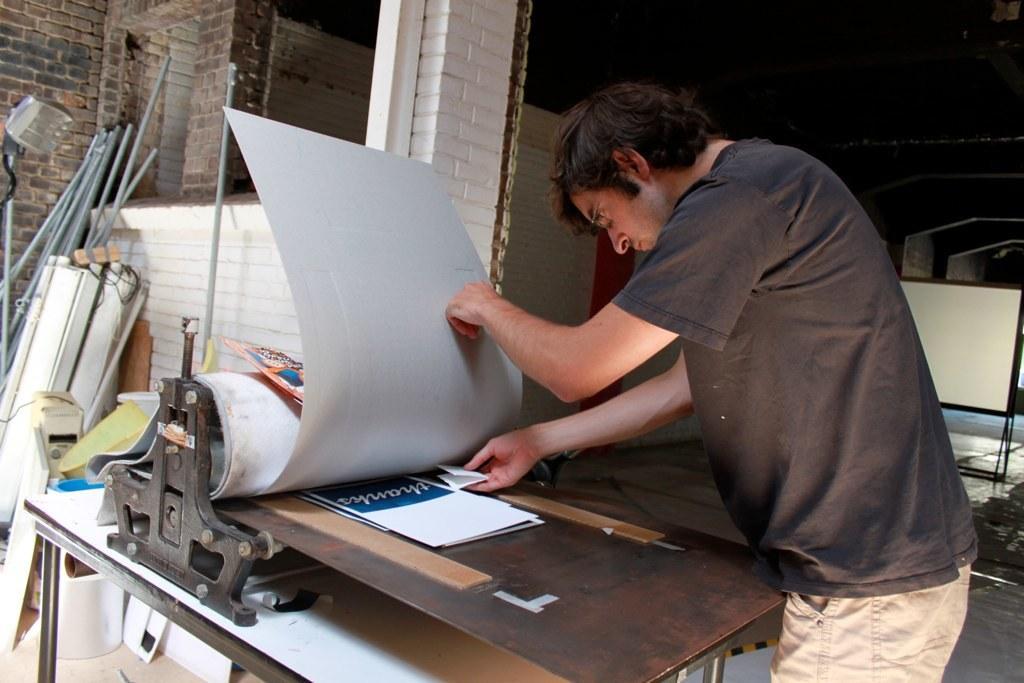Could you give a brief overview of what you see in this image? In this picture there is a man standing and holding the object. In the foreground there is a machine and there might be papers on the machine. At the back there are pipes and there are objects. On the right side of the image there is a board. At the bottom there is a floor. 